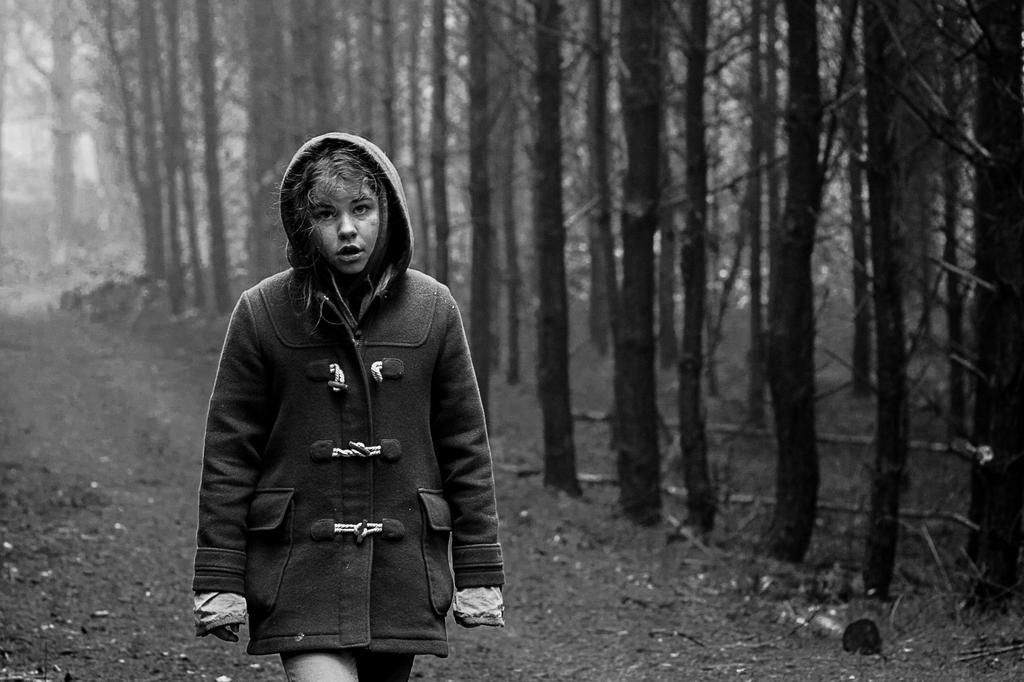Could you give a brief overview of what you see in this image? This image consists of a woman walking. She is wearing a black coat. On the right, there are trees. At the bottom, there is a ground. 